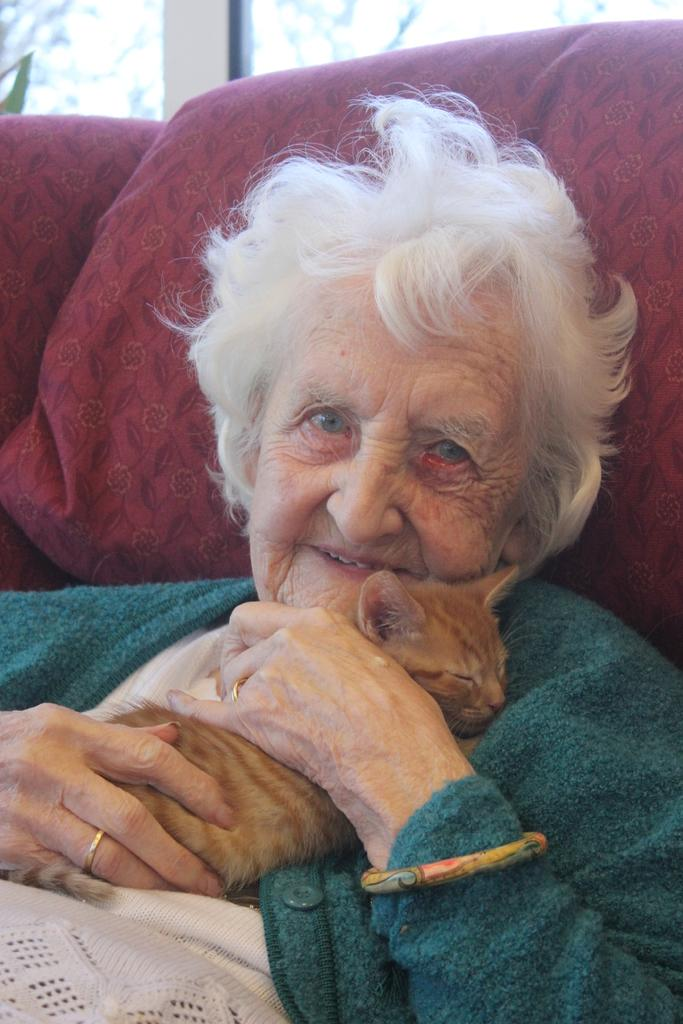Who is the main subject in the image? There is an old lady in the image. What is the old lady holding in the image? The old lady is holding a cat. What flavor of cream can be seen on the cat's fur in the image? There is no cream visible on the cat's fur in the image. 